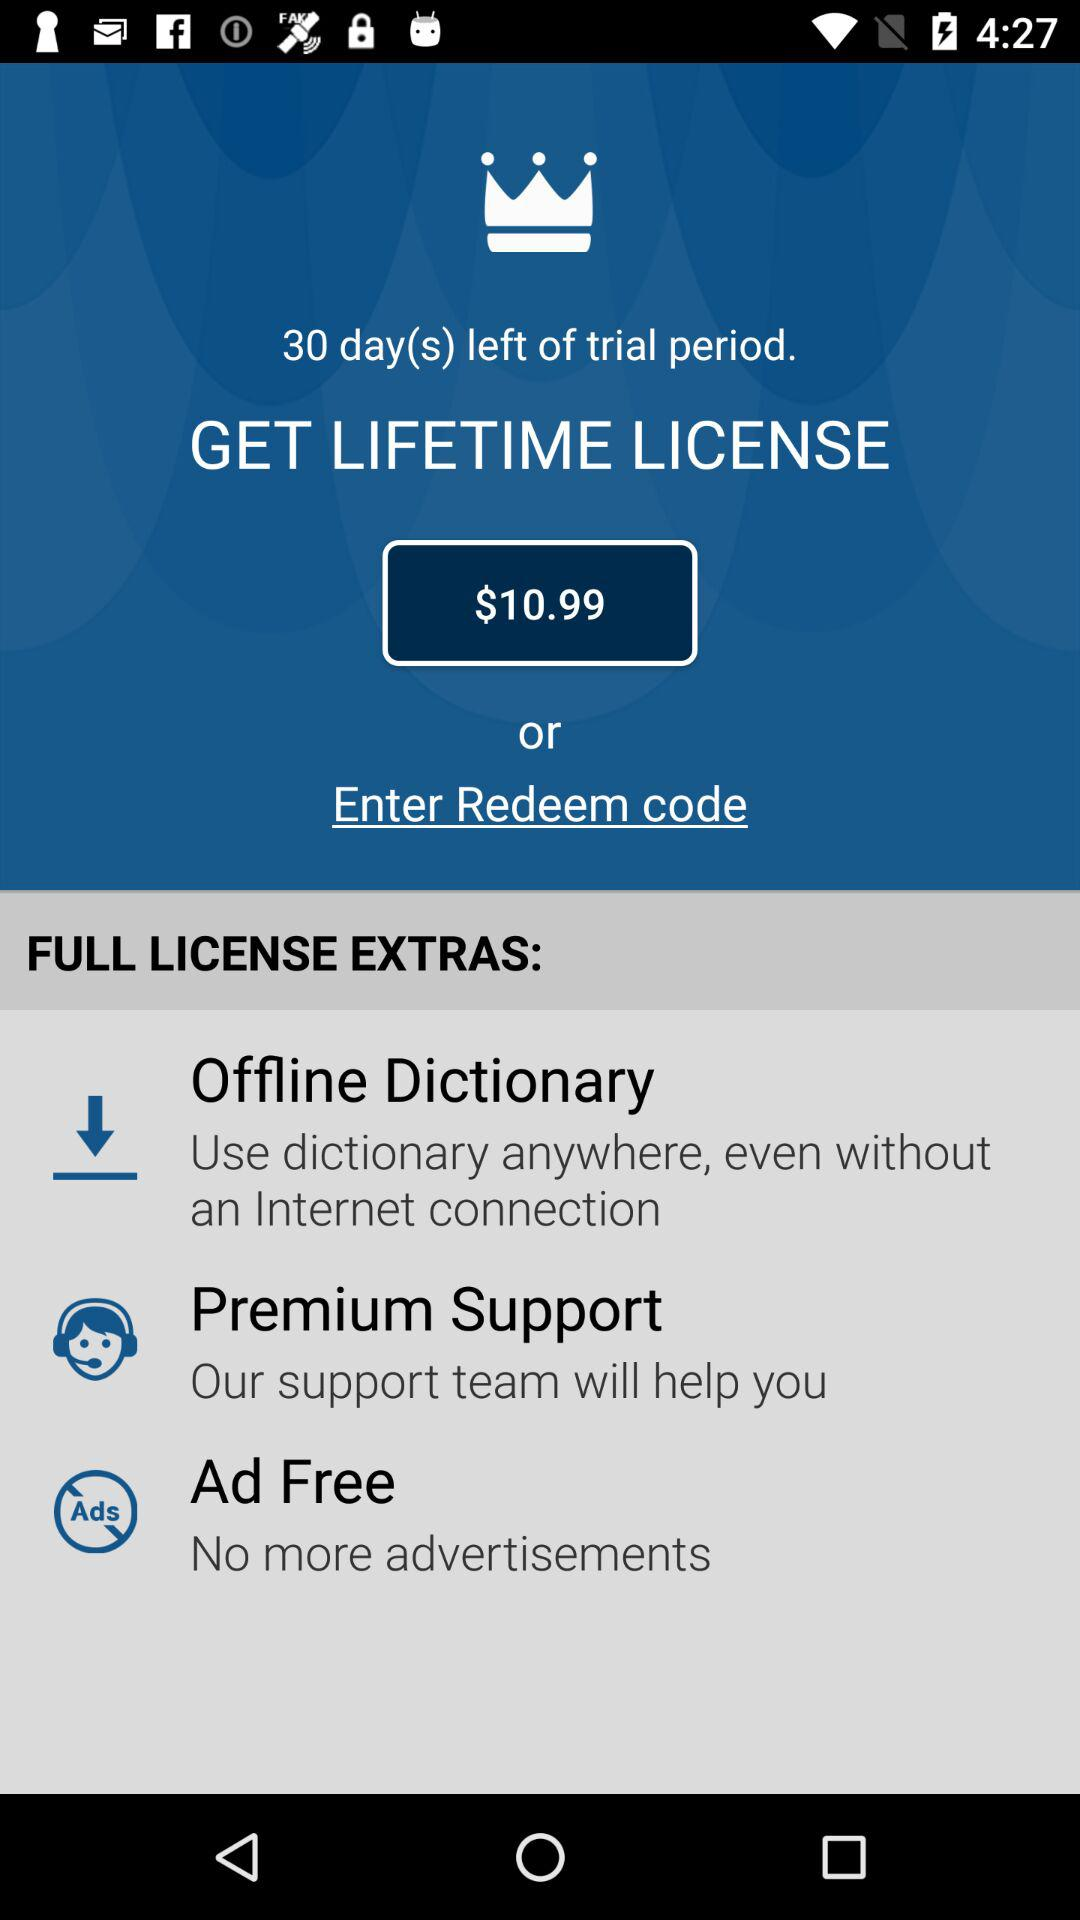How many extras are included with the lifetime license?
Answer the question using a single word or phrase. 3 